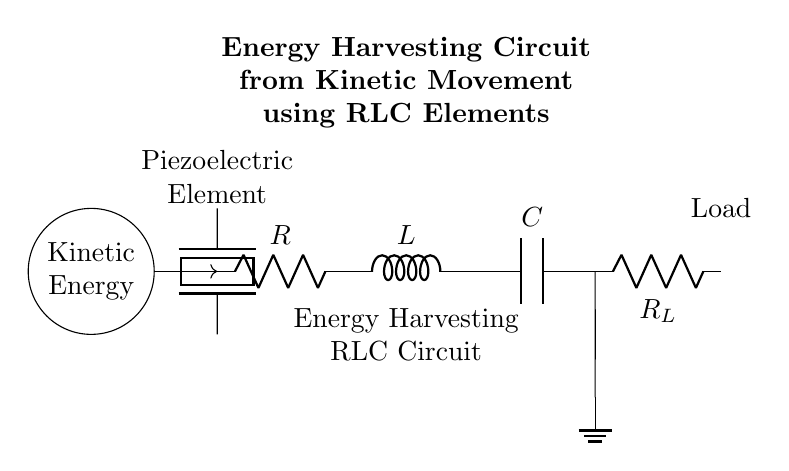What is the type of energy source in this circuit? The circuit features a kinetic energy source, which indicates that it harnesses energy from movement. This is visually represented by the circular symbol labeled "Kinetic Energy."
Answer: Kinetic energy What component type is represented by the label "C" in the circuit? The label "C" corresponds to a capacitor, which is a component that stores electrical energy in an electric field. It is specifically designed to store and release energy as needed in the circuit.
Answer: Capacitor What does the "R_L" in the circuit signify? "R_L" refers to the load resistance in the circuit, which is the component that consumes energy from the RLC circuit. It is depicted as a resistor connected at the output of the circuit.
Answer: Load resistance What are the three main components used in this RLC circuit? The three main components are a resistor (R), an inductor (L), and a capacitor (C), which together form a resonant circuit for energy harvesting. These components are arranged in series configuration in the circuit diagram.
Answer: Resistor, inductor, capacitor How is the piezoelectric element connected to the circuit? The piezoelectric element is connected in parallel with the RLC components and serves as the means to convert kinetic energy into electrical energy. This direct connection is shown by the dashed lines leading into the RLC circuit input.
Answer: In parallel What is the purpose of the inductor in the circuit? The inductor in the circuit helps to store energy in a magnetic field when current passes through it. It contributes to controlling current fluctuations and stabilizing the circuit's overall response to changes in energy input from the kinetic source.
Answer: To store energy What role does the RLC configuration play in energy harvesting? The RLC configuration is designed to tune the circuit for resonant energy harvesting, allowing it to efficiently convert kinetic energy into electrical energy by maximizing the energy transfer at a specific frequency. This tuning action is key in extracting usable electrical energy.
Answer: Resonant energy harvesting 